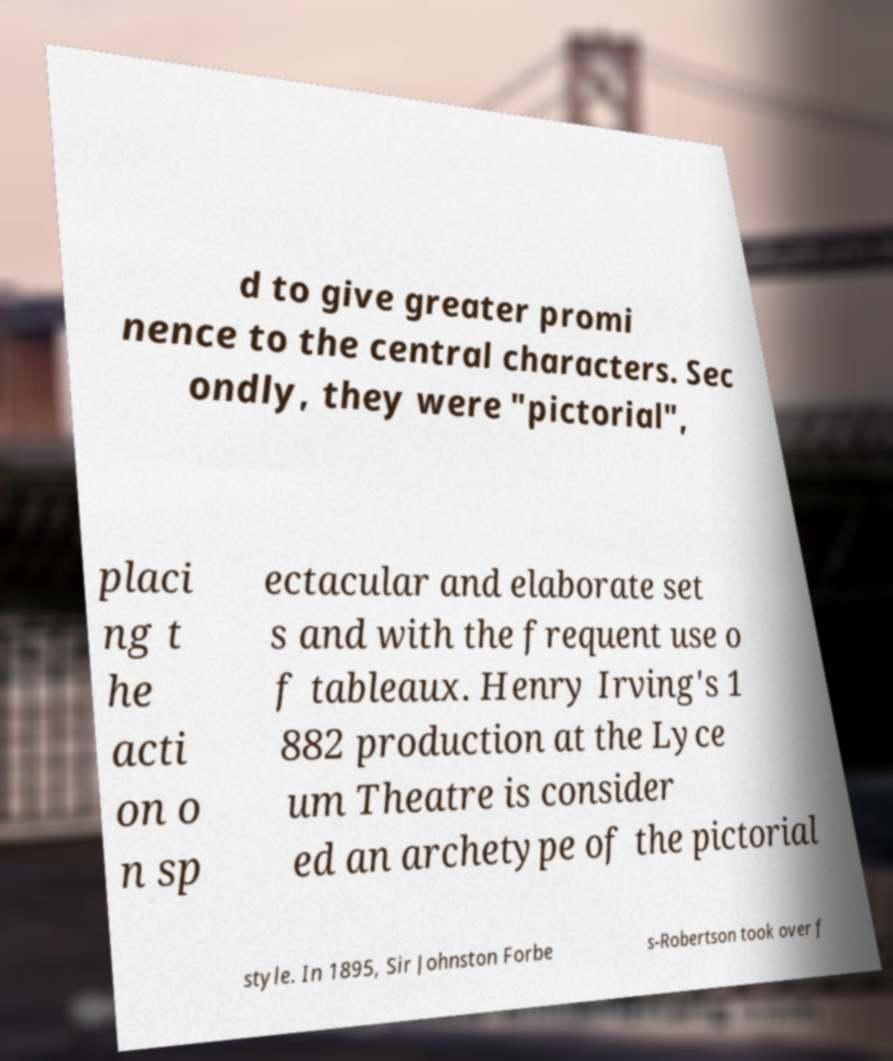Please identify and transcribe the text found in this image. d to give greater promi nence to the central characters. Sec ondly, they were "pictorial", placi ng t he acti on o n sp ectacular and elaborate set s and with the frequent use o f tableaux. Henry Irving's 1 882 production at the Lyce um Theatre is consider ed an archetype of the pictorial style. In 1895, Sir Johnston Forbe s-Robertson took over f 